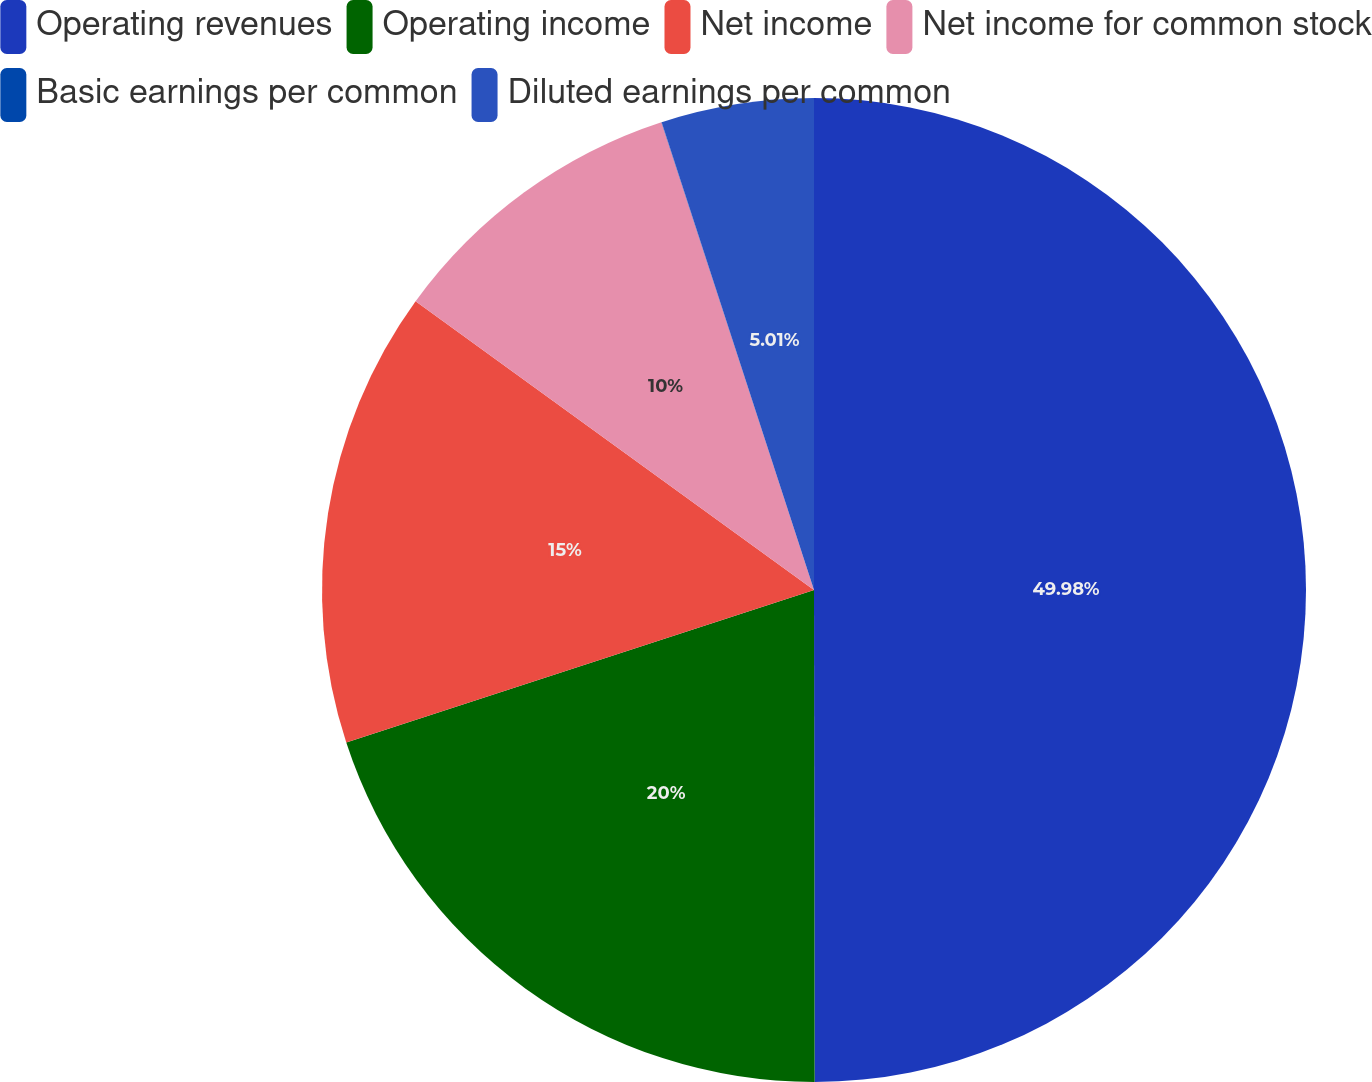<chart> <loc_0><loc_0><loc_500><loc_500><pie_chart><fcel>Operating revenues<fcel>Operating income<fcel>Net income<fcel>Net income for common stock<fcel>Basic earnings per common<fcel>Diluted earnings per common<nl><fcel>49.98%<fcel>20.0%<fcel>15.0%<fcel>10.0%<fcel>0.01%<fcel>5.01%<nl></chart> 